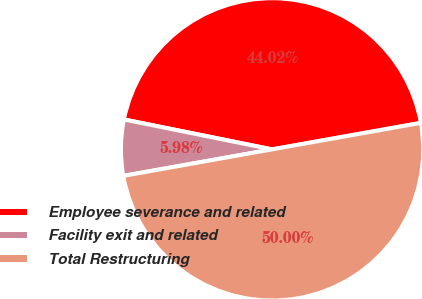Convert chart to OTSL. <chart><loc_0><loc_0><loc_500><loc_500><pie_chart><fcel>Employee severance and related<fcel>Facility exit and related<fcel>Total Restructuring<nl><fcel>44.02%<fcel>5.98%<fcel>50.0%<nl></chart> 